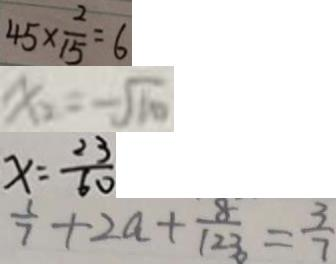Convert formula to latex. <formula><loc_0><loc_0><loc_500><loc_500>4 5 \times \frac { 2 } { 1 5 } = 6 
 x _ { 2 } = - \sqrt { 1 0 } 
 x = \frac { 2 3 } { 6 0 } 
 \frac { 1 } { 7 } + 2 a + \frac { 8 } { 1 2 3 } = \frac { 3 } { 7 }</formula> 